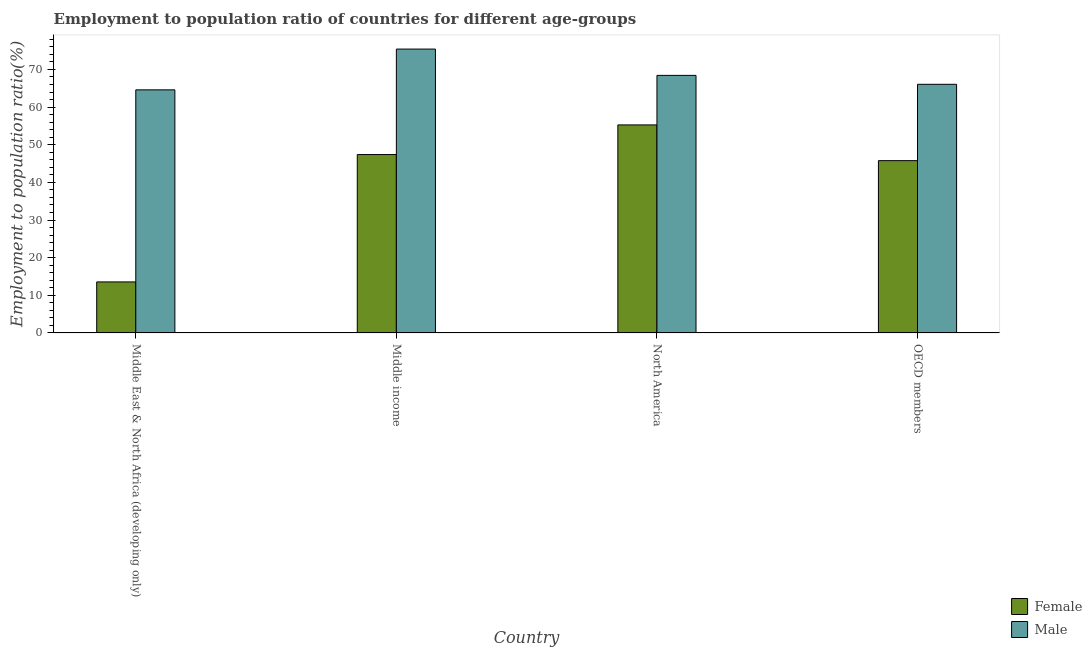How many different coloured bars are there?
Keep it short and to the point. 2. Are the number of bars per tick equal to the number of legend labels?
Your answer should be compact. Yes. How many bars are there on the 4th tick from the right?
Provide a succinct answer. 2. What is the employment to population ratio(female) in North America?
Ensure brevity in your answer.  55.26. Across all countries, what is the maximum employment to population ratio(male)?
Your response must be concise. 75.41. Across all countries, what is the minimum employment to population ratio(female)?
Provide a short and direct response. 13.56. In which country was the employment to population ratio(male) minimum?
Provide a short and direct response. Middle East & North Africa (developing only). What is the total employment to population ratio(female) in the graph?
Give a very brief answer. 161.97. What is the difference between the employment to population ratio(male) in Middle East & North Africa (developing only) and that in North America?
Your answer should be compact. -3.84. What is the difference between the employment to population ratio(female) in OECD members and the employment to population ratio(male) in Middle income?
Keep it short and to the point. -29.64. What is the average employment to population ratio(female) per country?
Your answer should be very brief. 40.49. What is the difference between the employment to population ratio(female) and employment to population ratio(male) in Middle East & North Africa (developing only)?
Offer a very short reply. -51.02. In how many countries, is the employment to population ratio(male) greater than 6 %?
Offer a very short reply. 4. What is the ratio of the employment to population ratio(female) in North America to that in OECD members?
Your response must be concise. 1.21. Is the difference between the employment to population ratio(male) in Middle East & North Africa (developing only) and OECD members greater than the difference between the employment to population ratio(female) in Middle East & North Africa (developing only) and OECD members?
Your answer should be very brief. Yes. What is the difference between the highest and the second highest employment to population ratio(female)?
Keep it short and to the point. 7.87. What is the difference between the highest and the lowest employment to population ratio(female)?
Keep it short and to the point. 41.7. In how many countries, is the employment to population ratio(male) greater than the average employment to population ratio(male) taken over all countries?
Your response must be concise. 1. Is the sum of the employment to population ratio(male) in Middle East & North Africa (developing only) and North America greater than the maximum employment to population ratio(female) across all countries?
Your response must be concise. Yes. What does the 1st bar from the right in North America represents?
Your answer should be compact. Male. How many bars are there?
Make the answer very short. 8. Are all the bars in the graph horizontal?
Give a very brief answer. No. Does the graph contain grids?
Your answer should be compact. No. Where does the legend appear in the graph?
Your answer should be compact. Bottom right. How many legend labels are there?
Your answer should be compact. 2. What is the title of the graph?
Offer a terse response. Employment to population ratio of countries for different age-groups. What is the label or title of the X-axis?
Your response must be concise. Country. What is the label or title of the Y-axis?
Your response must be concise. Employment to population ratio(%). What is the Employment to population ratio(%) of Female in Middle East & North Africa (developing only)?
Your response must be concise. 13.56. What is the Employment to population ratio(%) in Male in Middle East & North Africa (developing only)?
Provide a short and direct response. 64.58. What is the Employment to population ratio(%) in Female in Middle income?
Make the answer very short. 47.39. What is the Employment to population ratio(%) of Male in Middle income?
Provide a succinct answer. 75.41. What is the Employment to population ratio(%) of Female in North America?
Offer a terse response. 55.26. What is the Employment to population ratio(%) of Male in North America?
Offer a terse response. 68.42. What is the Employment to population ratio(%) of Female in OECD members?
Offer a terse response. 45.77. What is the Employment to population ratio(%) of Male in OECD members?
Your answer should be very brief. 66.05. Across all countries, what is the maximum Employment to population ratio(%) of Female?
Your answer should be compact. 55.26. Across all countries, what is the maximum Employment to population ratio(%) in Male?
Keep it short and to the point. 75.41. Across all countries, what is the minimum Employment to population ratio(%) in Female?
Your answer should be compact. 13.56. Across all countries, what is the minimum Employment to population ratio(%) of Male?
Ensure brevity in your answer.  64.58. What is the total Employment to population ratio(%) in Female in the graph?
Provide a short and direct response. 161.97. What is the total Employment to population ratio(%) of Male in the graph?
Offer a terse response. 274.45. What is the difference between the Employment to population ratio(%) in Female in Middle East & North Africa (developing only) and that in Middle income?
Provide a short and direct response. -33.83. What is the difference between the Employment to population ratio(%) in Male in Middle East & North Africa (developing only) and that in Middle income?
Your response must be concise. -10.83. What is the difference between the Employment to population ratio(%) of Female in Middle East & North Africa (developing only) and that in North America?
Your answer should be very brief. -41.7. What is the difference between the Employment to population ratio(%) of Male in Middle East & North Africa (developing only) and that in North America?
Provide a short and direct response. -3.84. What is the difference between the Employment to population ratio(%) in Female in Middle East & North Africa (developing only) and that in OECD members?
Your answer should be compact. -32.21. What is the difference between the Employment to population ratio(%) in Male in Middle East & North Africa (developing only) and that in OECD members?
Make the answer very short. -1.47. What is the difference between the Employment to population ratio(%) of Female in Middle income and that in North America?
Offer a very short reply. -7.87. What is the difference between the Employment to population ratio(%) in Male in Middle income and that in North America?
Provide a short and direct response. 6.99. What is the difference between the Employment to population ratio(%) of Female in Middle income and that in OECD members?
Provide a succinct answer. 1.62. What is the difference between the Employment to population ratio(%) in Male in Middle income and that in OECD members?
Give a very brief answer. 9.36. What is the difference between the Employment to population ratio(%) of Female in North America and that in OECD members?
Give a very brief answer. 9.49. What is the difference between the Employment to population ratio(%) of Male in North America and that in OECD members?
Your answer should be very brief. 2.37. What is the difference between the Employment to population ratio(%) of Female in Middle East & North Africa (developing only) and the Employment to population ratio(%) of Male in Middle income?
Provide a succinct answer. -61.85. What is the difference between the Employment to population ratio(%) of Female in Middle East & North Africa (developing only) and the Employment to population ratio(%) of Male in North America?
Give a very brief answer. -54.86. What is the difference between the Employment to population ratio(%) of Female in Middle East & North Africa (developing only) and the Employment to population ratio(%) of Male in OECD members?
Make the answer very short. -52.49. What is the difference between the Employment to population ratio(%) of Female in Middle income and the Employment to population ratio(%) of Male in North America?
Offer a terse response. -21.03. What is the difference between the Employment to population ratio(%) in Female in Middle income and the Employment to population ratio(%) in Male in OECD members?
Keep it short and to the point. -18.66. What is the difference between the Employment to population ratio(%) of Female in North America and the Employment to population ratio(%) of Male in OECD members?
Offer a terse response. -10.79. What is the average Employment to population ratio(%) in Female per country?
Ensure brevity in your answer.  40.49. What is the average Employment to population ratio(%) in Male per country?
Your answer should be very brief. 68.61. What is the difference between the Employment to population ratio(%) of Female and Employment to population ratio(%) of Male in Middle East & North Africa (developing only)?
Your answer should be very brief. -51.02. What is the difference between the Employment to population ratio(%) in Female and Employment to population ratio(%) in Male in Middle income?
Ensure brevity in your answer.  -28.02. What is the difference between the Employment to population ratio(%) in Female and Employment to population ratio(%) in Male in North America?
Give a very brief answer. -13.16. What is the difference between the Employment to population ratio(%) of Female and Employment to population ratio(%) of Male in OECD members?
Make the answer very short. -20.28. What is the ratio of the Employment to population ratio(%) of Female in Middle East & North Africa (developing only) to that in Middle income?
Offer a terse response. 0.29. What is the ratio of the Employment to population ratio(%) of Male in Middle East & North Africa (developing only) to that in Middle income?
Offer a terse response. 0.86. What is the ratio of the Employment to population ratio(%) of Female in Middle East & North Africa (developing only) to that in North America?
Offer a very short reply. 0.25. What is the ratio of the Employment to population ratio(%) in Male in Middle East & North Africa (developing only) to that in North America?
Your response must be concise. 0.94. What is the ratio of the Employment to population ratio(%) in Female in Middle East & North Africa (developing only) to that in OECD members?
Ensure brevity in your answer.  0.3. What is the ratio of the Employment to population ratio(%) of Male in Middle East & North Africa (developing only) to that in OECD members?
Your answer should be very brief. 0.98. What is the ratio of the Employment to population ratio(%) of Female in Middle income to that in North America?
Your answer should be compact. 0.86. What is the ratio of the Employment to population ratio(%) of Male in Middle income to that in North America?
Your answer should be compact. 1.1. What is the ratio of the Employment to population ratio(%) of Female in Middle income to that in OECD members?
Make the answer very short. 1.04. What is the ratio of the Employment to population ratio(%) of Male in Middle income to that in OECD members?
Ensure brevity in your answer.  1.14. What is the ratio of the Employment to population ratio(%) in Female in North America to that in OECD members?
Provide a short and direct response. 1.21. What is the ratio of the Employment to population ratio(%) of Male in North America to that in OECD members?
Give a very brief answer. 1.04. What is the difference between the highest and the second highest Employment to population ratio(%) of Female?
Your answer should be very brief. 7.87. What is the difference between the highest and the second highest Employment to population ratio(%) in Male?
Give a very brief answer. 6.99. What is the difference between the highest and the lowest Employment to population ratio(%) in Female?
Your response must be concise. 41.7. What is the difference between the highest and the lowest Employment to population ratio(%) of Male?
Offer a very short reply. 10.83. 